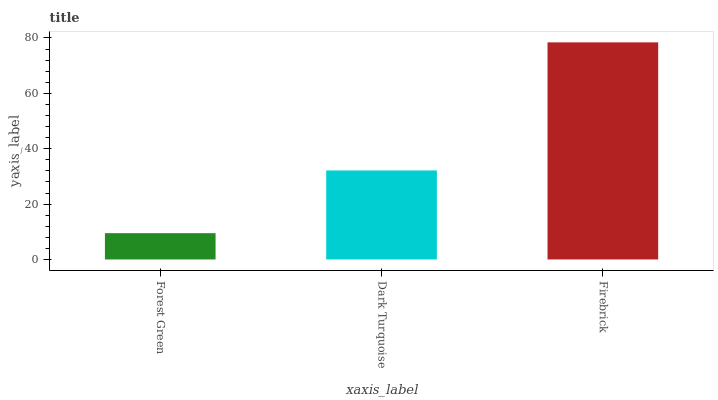Is Firebrick the maximum?
Answer yes or no. Yes. Is Dark Turquoise the minimum?
Answer yes or no. No. Is Dark Turquoise the maximum?
Answer yes or no. No. Is Dark Turquoise greater than Forest Green?
Answer yes or no. Yes. Is Forest Green less than Dark Turquoise?
Answer yes or no. Yes. Is Forest Green greater than Dark Turquoise?
Answer yes or no. No. Is Dark Turquoise less than Forest Green?
Answer yes or no. No. Is Dark Turquoise the high median?
Answer yes or no. Yes. Is Dark Turquoise the low median?
Answer yes or no. Yes. Is Firebrick the high median?
Answer yes or no. No. Is Firebrick the low median?
Answer yes or no. No. 